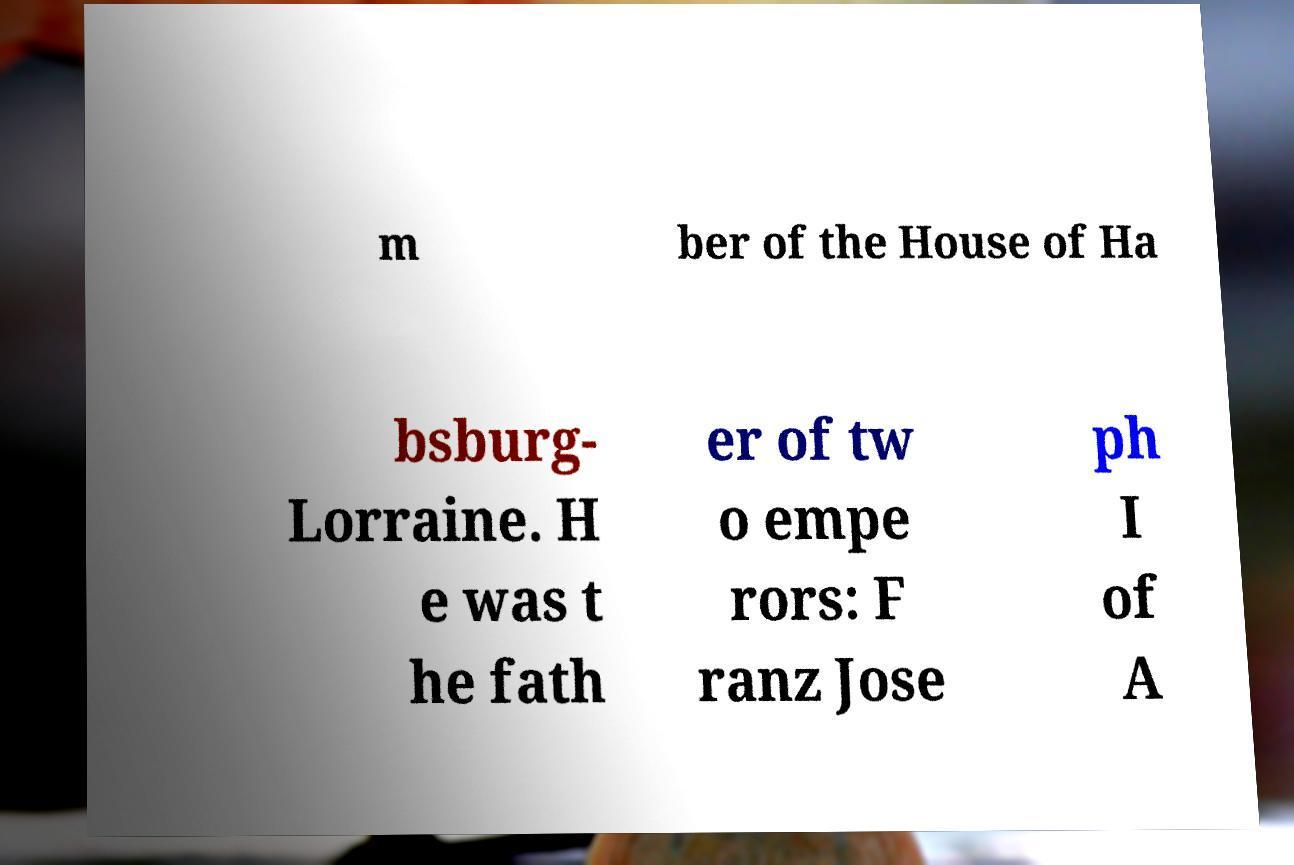There's text embedded in this image that I need extracted. Can you transcribe it verbatim? m ber of the House of Ha bsburg- Lorraine. H e was t he fath er of tw o empe rors: F ranz Jose ph I of A 